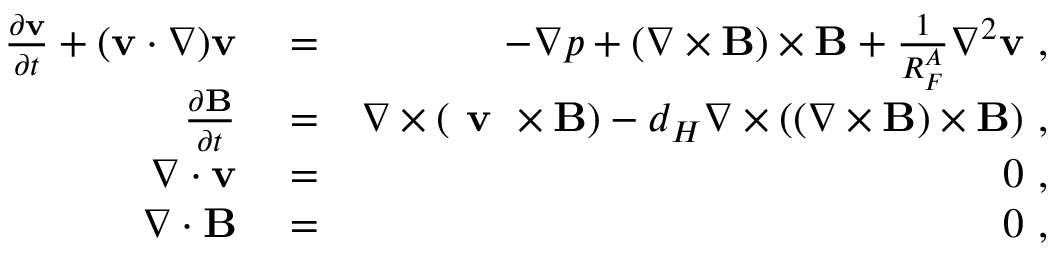Convert formula to latex. <formula><loc_0><loc_0><loc_500><loc_500>\begin{array} { r l r } { \frac { \partial { v } } { \partial t } + ( { v } \cdot \nabla ) { v } } & = } & { - \nabla p + ( \nabla \times { B } ) \times { B } + \frac { 1 } { R _ { F } ^ { A } } \nabla ^ { 2 } { v } , } \\ { \frac { \partial { B } } { \partial t } } & = } & { \nabla \times ( v \times { B } ) - d _ { H } \nabla \times ( ( \nabla \times { B } ) \times { B } ) , } \\ { \nabla \cdot { v } } & = } & { 0 , } \\ { \nabla \cdot { B } } & = } & { 0 , } \end{array}</formula> 